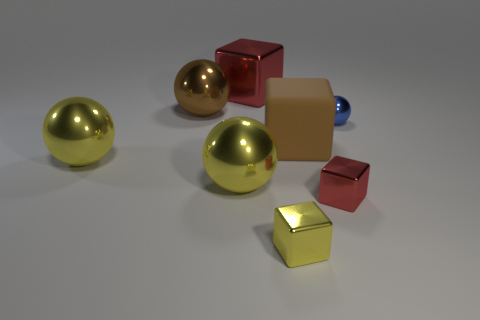Subtract 1 spheres. How many spheres are left? 3 Add 1 brown rubber cubes. How many objects exist? 9 Add 4 blue balls. How many blue balls are left? 5 Add 7 blue objects. How many blue objects exist? 8 Subtract 1 brown blocks. How many objects are left? 7 Subtract all cyan shiny blocks. Subtract all small red metal things. How many objects are left? 7 